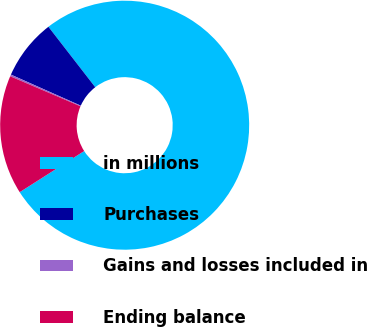Convert chart to OTSL. <chart><loc_0><loc_0><loc_500><loc_500><pie_chart><fcel>in millions<fcel>Purchases<fcel>Gains and losses included in<fcel>Ending balance<nl><fcel>76.45%<fcel>7.85%<fcel>0.23%<fcel>15.47%<nl></chart> 